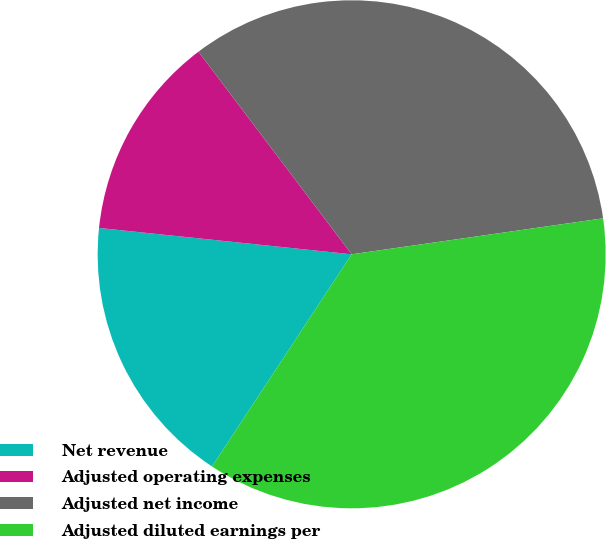<chart> <loc_0><loc_0><loc_500><loc_500><pie_chart><fcel>Net revenue<fcel>Adjusted operating expenses<fcel>Adjusted net income<fcel>Adjusted diluted earnings per<nl><fcel>17.39%<fcel>13.04%<fcel>33.04%<fcel>36.52%<nl></chart> 